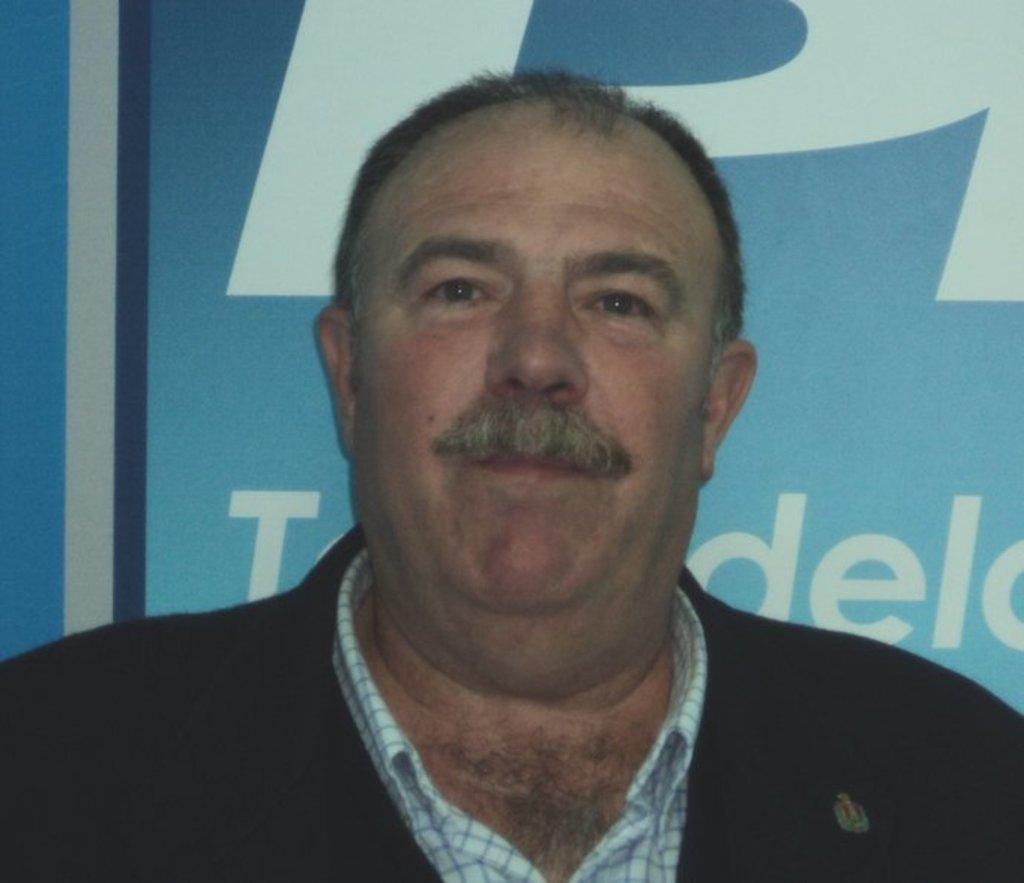Describe this image in one or two sentences. In this picture I can see a man, and in the background there is a board. 